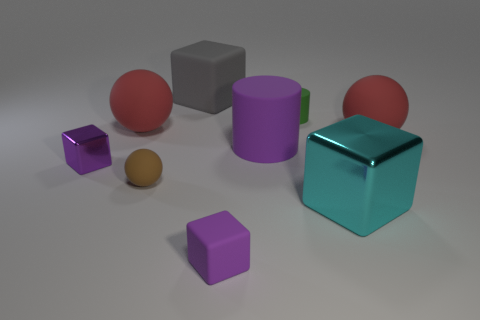What size is the purple thing that is in front of the matte ball that is in front of the tiny block to the left of the tiny rubber ball?
Ensure brevity in your answer.  Small. How big is the red rubber object on the left side of the large metallic thing?
Give a very brief answer. Large. What shape is the object that is the same material as the large cyan block?
Offer a very short reply. Cube. Does the large thing to the left of the small brown sphere have the same material as the cyan thing?
Make the answer very short. No. What number of other objects are the same material as the tiny green cylinder?
Ensure brevity in your answer.  6. What number of things are either matte things to the left of the big shiny thing or tiny purple blocks that are to the right of the tiny purple shiny block?
Ensure brevity in your answer.  6. There is a large red rubber object that is on the right side of the tiny green cylinder; does it have the same shape as the matte thing that is in front of the large cyan metallic object?
Give a very brief answer. No. The purple metallic thing that is the same size as the brown sphere is what shape?
Offer a very short reply. Cube. How many matte objects are red cubes or large cylinders?
Make the answer very short. 1. Is the material of the big object to the right of the big shiny object the same as the big red thing that is to the left of the gray rubber object?
Provide a succinct answer. Yes. 